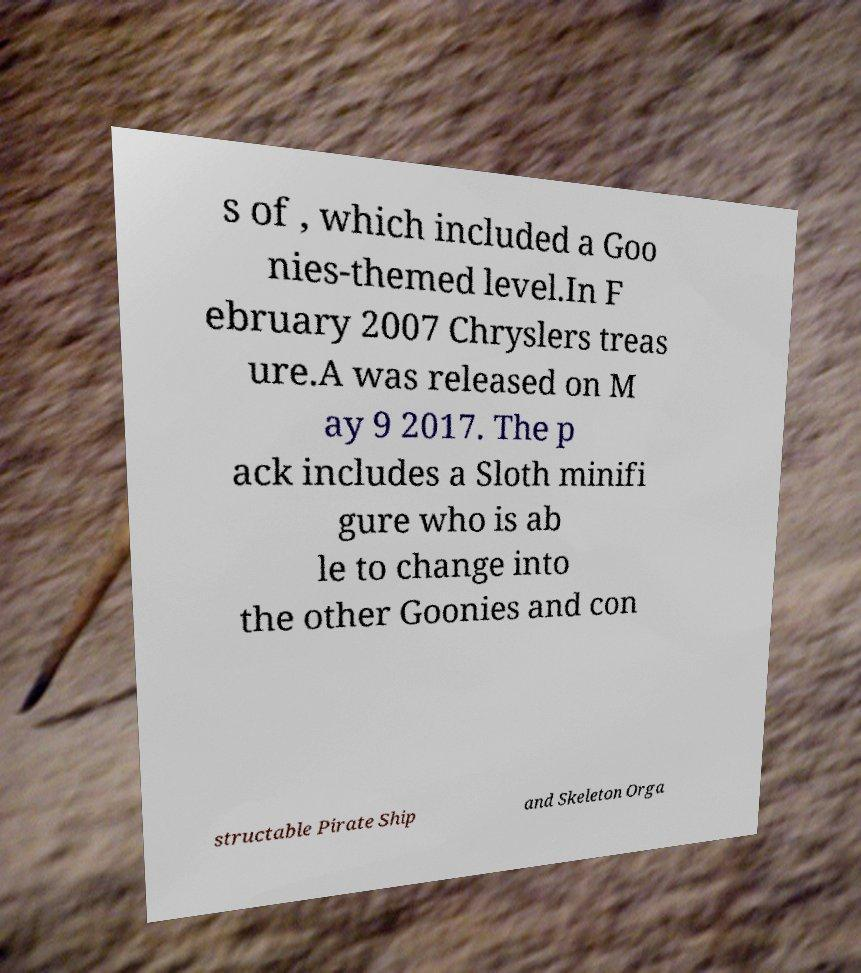I need the written content from this picture converted into text. Can you do that? s of , which included a Goo nies-themed level.In F ebruary 2007 Chryslers treas ure.A was released on M ay 9 2017. The p ack includes a Sloth minifi gure who is ab le to change into the other Goonies and con structable Pirate Ship and Skeleton Orga 